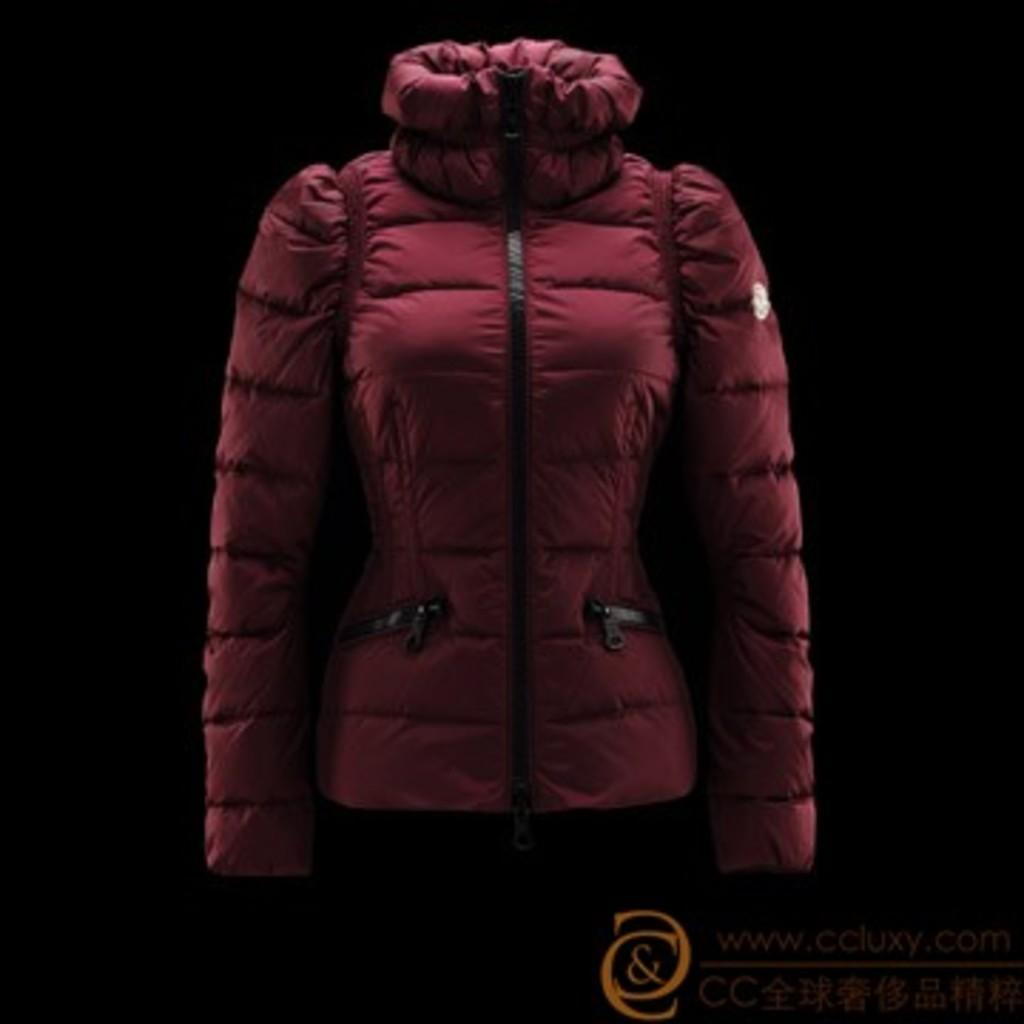What color is the jacket that is visible in the image? There is a maroon color jacket in the image. What other feature can be seen on the right side of the image? There is an orange color watermark on the right side of the image. How would you describe the background of the image? The background of the image is completely dark. How many balloons are floating in the background of the image? There are no balloons present in the image; the background is completely dark. What is the amount of rest that can be seen in the image? There is no indication of rest or relaxation in the image, as it primarily features a jacket and a watermark. 